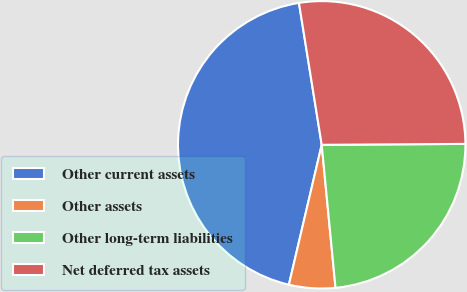Convert chart. <chart><loc_0><loc_0><loc_500><loc_500><pie_chart><fcel>Other current assets<fcel>Other assets<fcel>Other long-term liabilities<fcel>Net deferred tax assets<nl><fcel>43.8%<fcel>5.2%<fcel>23.57%<fcel>27.43%<nl></chart> 